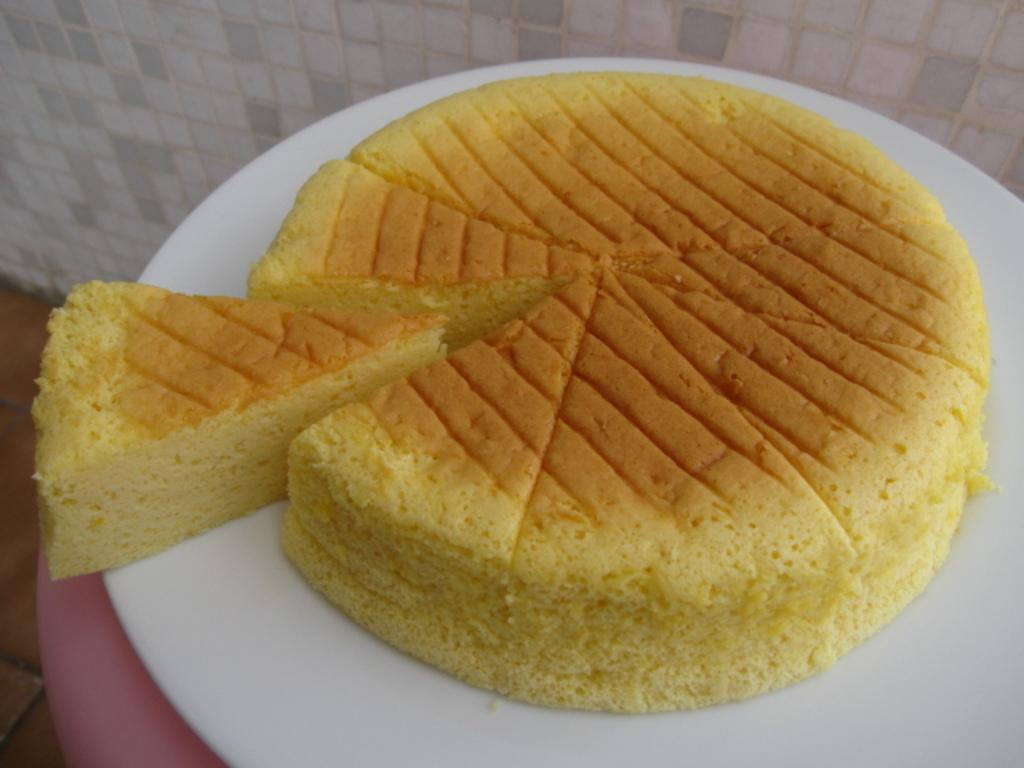What type of wall is visible in the image? There is a marble wall in the image. Where is the marble wall located in relation to the other elements in the image? The marble wall is on the backside. What type of food can be seen in the image? There is a cake on a plate in the image. What type of bread can be seen on the hill in the image? There is no bread or hill present in the image; it only features a marble wall and a cake on a plate. Is there a crown visible on the marble wall in the image? There is no crown present on the marble wall in the image. 